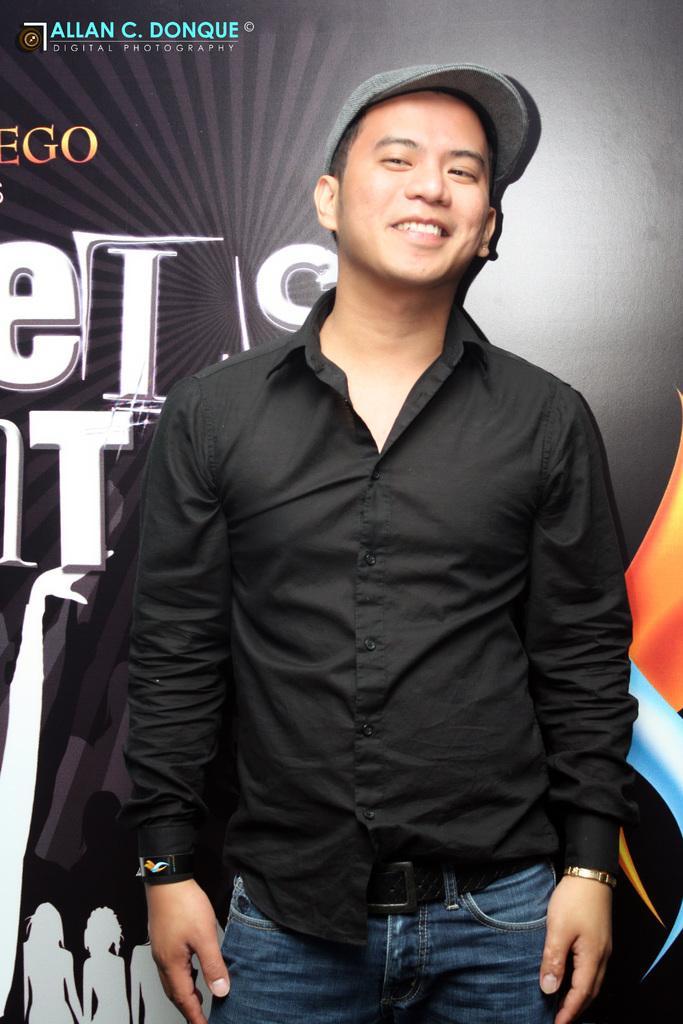Could you give a brief overview of what you see in this image? In this picture there is a man who is standing at the center of the image, he is posing to the front direction, he is wearing a grey color cap and there is a poster behind him. 